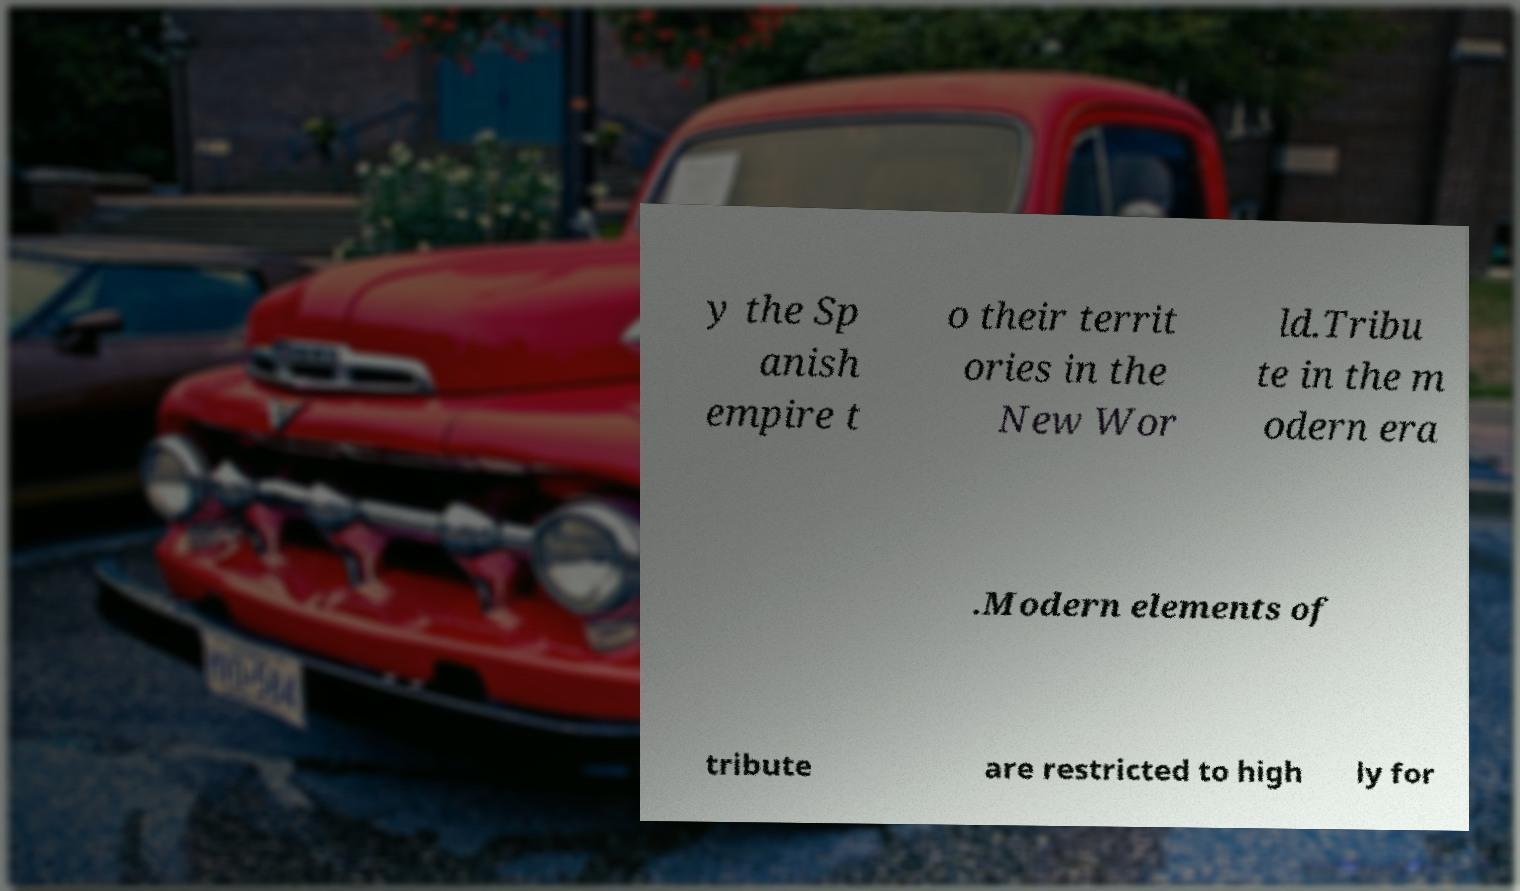There's text embedded in this image that I need extracted. Can you transcribe it verbatim? y the Sp anish empire t o their territ ories in the New Wor ld.Tribu te in the m odern era .Modern elements of tribute are restricted to high ly for 